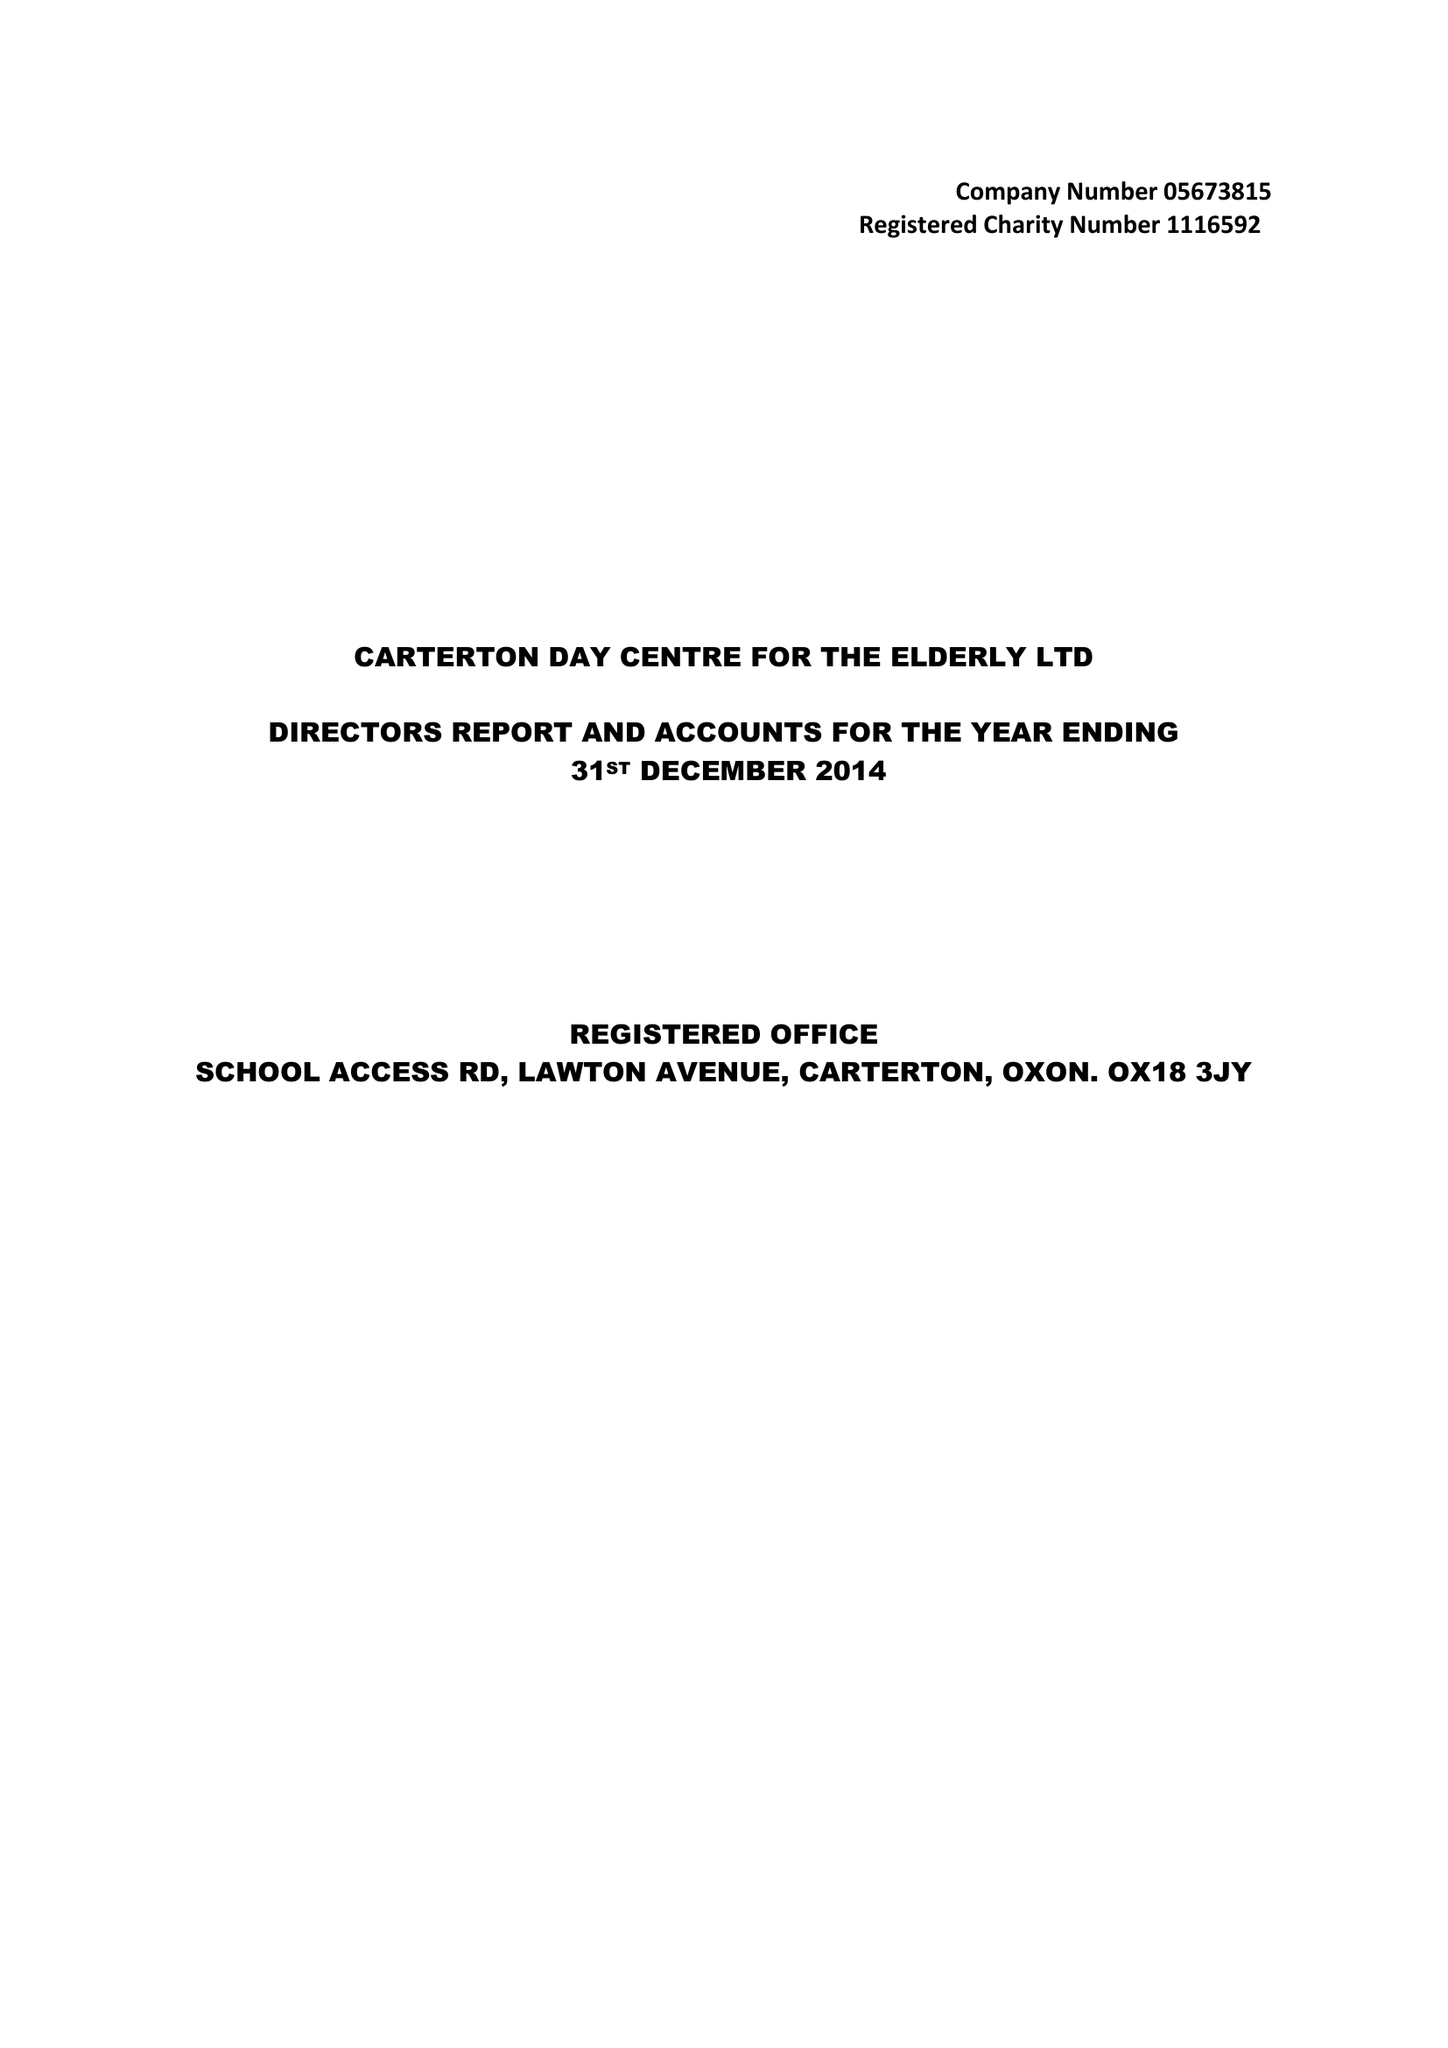What is the value for the address__street_line?
Answer the question using a single word or phrase. LAWTON AVENUE 